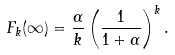<formula> <loc_0><loc_0><loc_500><loc_500>F _ { k } ( \infty ) = \frac { \alpha } { k } \left ( \frac { 1 } { 1 + \alpha } \right ) ^ { k } .</formula> 